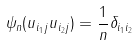Convert formula to latex. <formula><loc_0><loc_0><loc_500><loc_500>\psi _ { n } ( u _ { i _ { 1 } j } u _ { i _ { 2 } j } ) = \frac { 1 } { n } \delta _ { i _ { 1 } i _ { 2 } }</formula> 